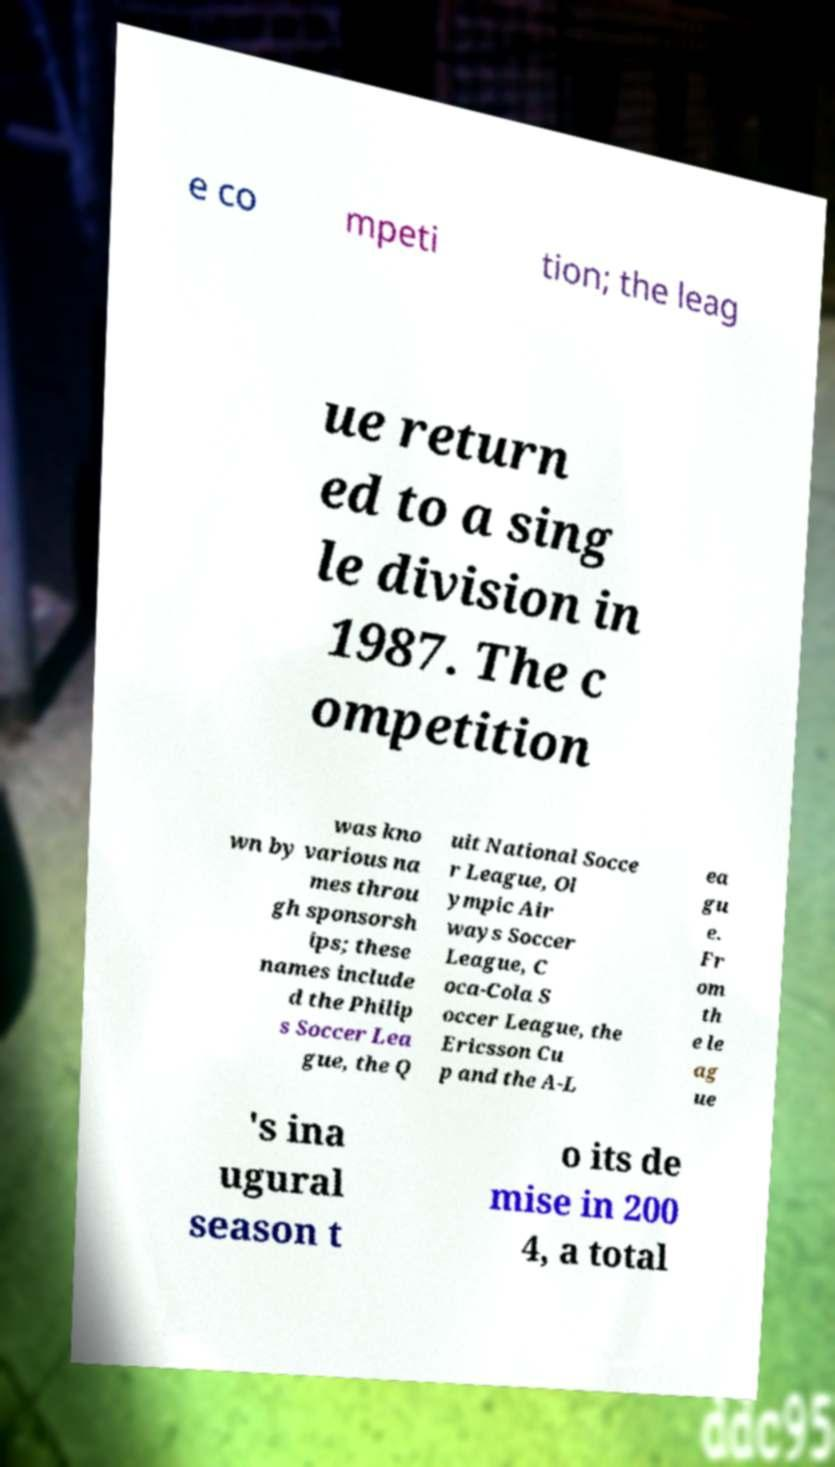Can you read and provide the text displayed in the image?This photo seems to have some interesting text. Can you extract and type it out for me? e co mpeti tion; the leag ue return ed to a sing le division in 1987. The c ompetition was kno wn by various na mes throu gh sponsorsh ips; these names include d the Philip s Soccer Lea gue, the Q uit National Socce r League, Ol ympic Air ways Soccer League, C oca-Cola S occer League, the Ericsson Cu p and the A-L ea gu e. Fr om th e le ag ue 's ina ugural season t o its de mise in 200 4, a total 